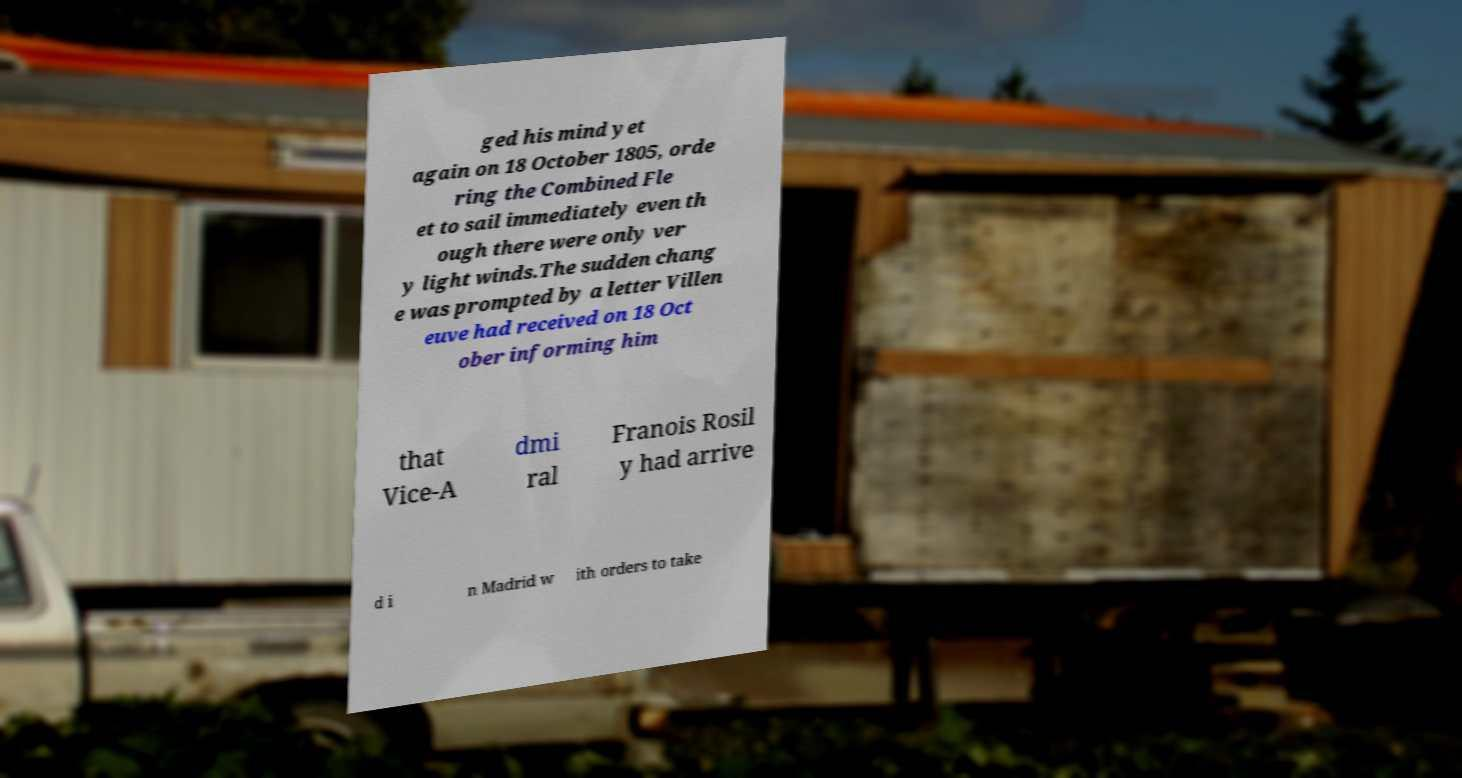There's text embedded in this image that I need extracted. Can you transcribe it verbatim? ged his mind yet again on 18 October 1805, orde ring the Combined Fle et to sail immediately even th ough there were only ver y light winds.The sudden chang e was prompted by a letter Villen euve had received on 18 Oct ober informing him that Vice-A dmi ral Franois Rosil y had arrive d i n Madrid w ith orders to take 